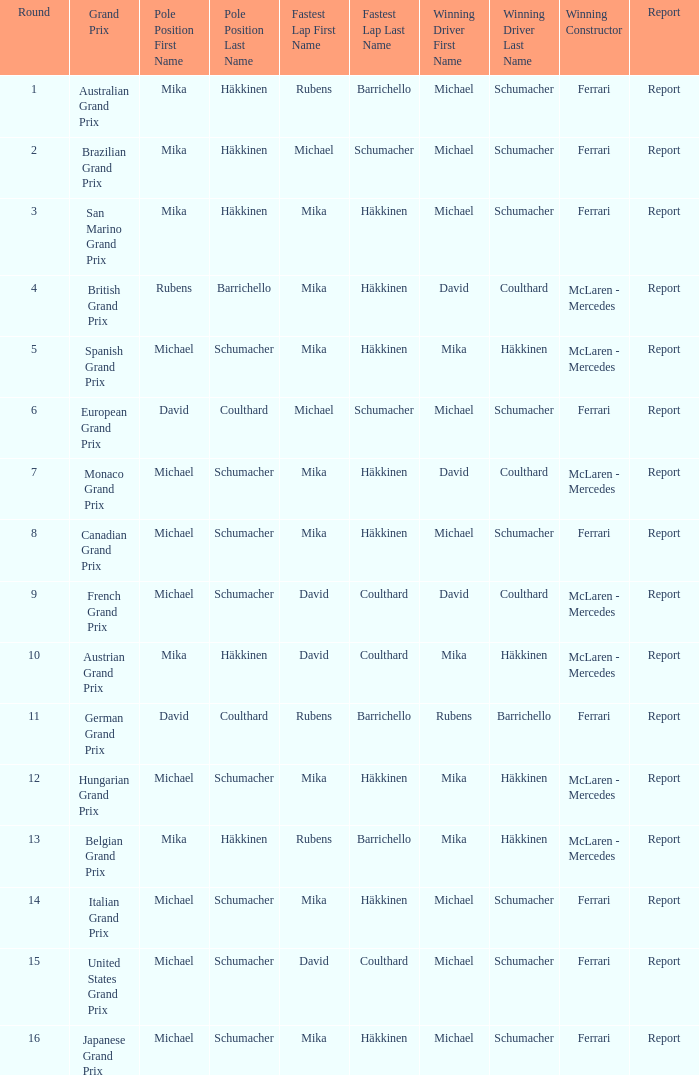Who had the fastest lap in the Belgian Grand Prix? Rubens Barrichello. 